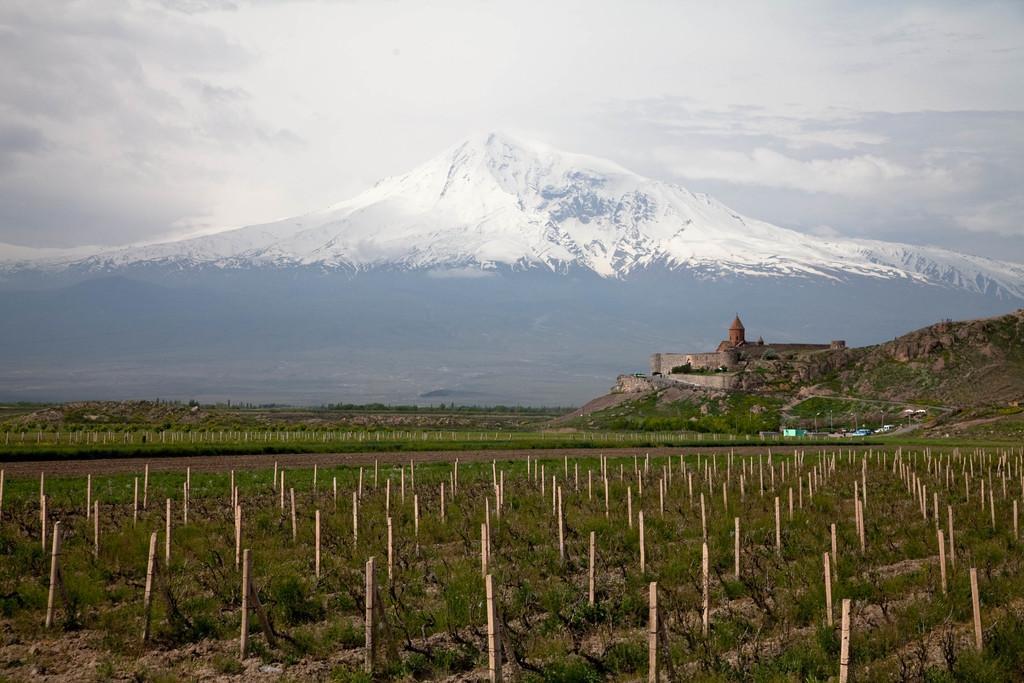Describe this image in one or two sentences. In this image there are wooden pole in a field, in the background there is a mountain, on that mountain there is a temple, there is another mountain covered with snow. 